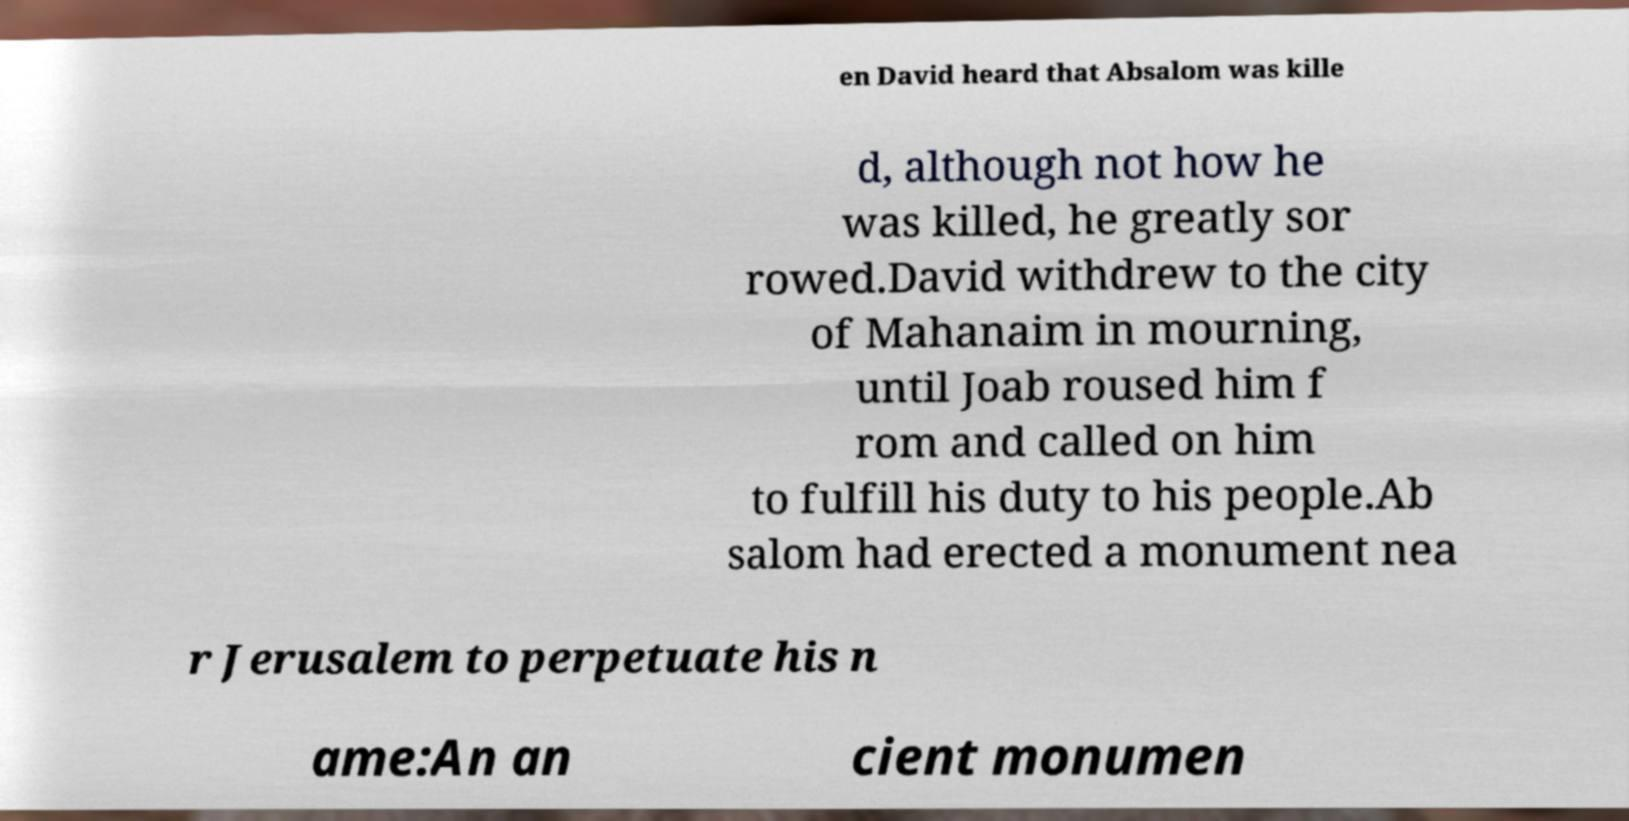There's text embedded in this image that I need extracted. Can you transcribe it verbatim? en David heard that Absalom was kille d, although not how he was killed, he greatly sor rowed.David withdrew to the city of Mahanaim in mourning, until Joab roused him f rom and called on him to fulfill his duty to his people.Ab salom had erected a monument nea r Jerusalem to perpetuate his n ame:An an cient monumen 